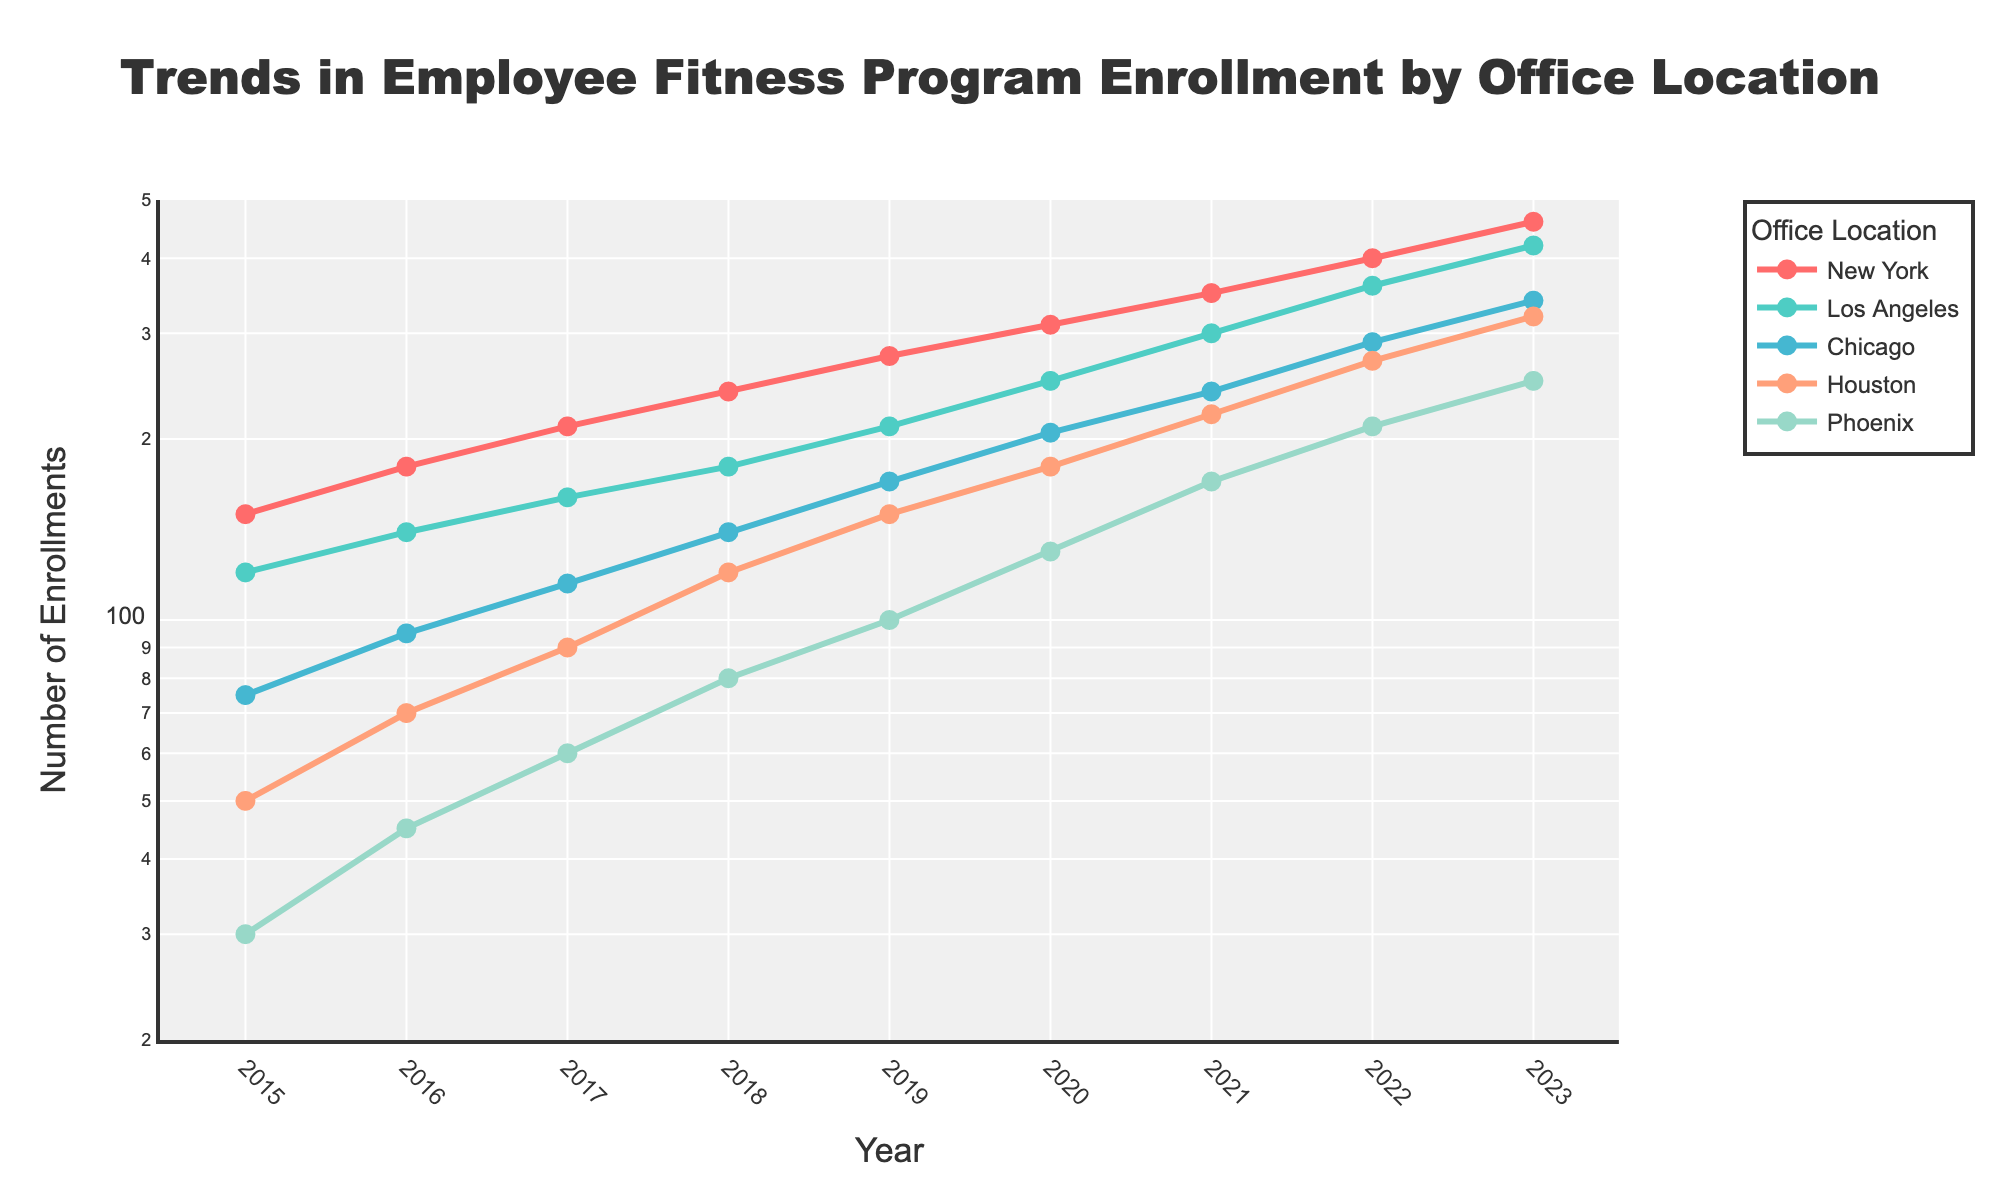What is the title of the line plot? The title appears prominently at the top of the plot. It reads "Trends in Employee Fitness Program Enrollment by Office Location".
Answer: Trends in Employee Fitness Program Enrollment by Office Location Which office location had the highest number of enrollments in 2023? By locating the 2023 data on the x-axis and looking at the highest y-value, we see that New York had the highest number of enrollments.
Answer: New York Around which year did Phoenix's enrollments surpass 100? By examining Phoenix's line, it appears the yearly values exceed 100 slightly before or around 2019.
Answer: 2019 What is the range of enrollment numbers on the y-axis? The y-axis of the plot is on a log scale and spans from approximately 20 to 500 enrollments.
Answer: 20 to 500 Which office showed the most significant increase in enrollments from 2015 to 2023? By comparing the start and end points of each line, New York has the steepest slope, indicating the most significant increase.
Answer: New York How have enrollments in Chicago changed from 2017 to 2021? Identifying data points for Chicago from 2017 to 2021, enrollment rose from 115 to 240, indicating an increase of 125.
Answer: Increased by 125 What is the difference in enrollments between Los Angeles and Houston in 2020? Examining the values for 2020, Los Angeles had 250 enrollments, and Houston had 180. The difference is 250-180 = 70.
Answer: 70 In which year did Houston's enrollments match those of Phoenix in the previous year? Checking Houston's 2021 value (220) against Phoenix's 2020 value (130) shows no match, but checking Houston's 2020 value (180) against Phoenix's 2019 value (100) shows a match around 2020.
Answer: 2020 Which city had the smallest number of enrollments in 2017, and how many were there? Reviewing 2017 data, Phoenix has the smallest number of enrollments, which is 60.
Answer: Phoenix, 60 How do New York's enrollments compare to Los Angeles's from 2015 to 2023? The New York line is consistently higher than the Los Angeles line, indicating New York had more enrollments every year from 2015 to 2023.
Answer: New York had more enrollments every year 